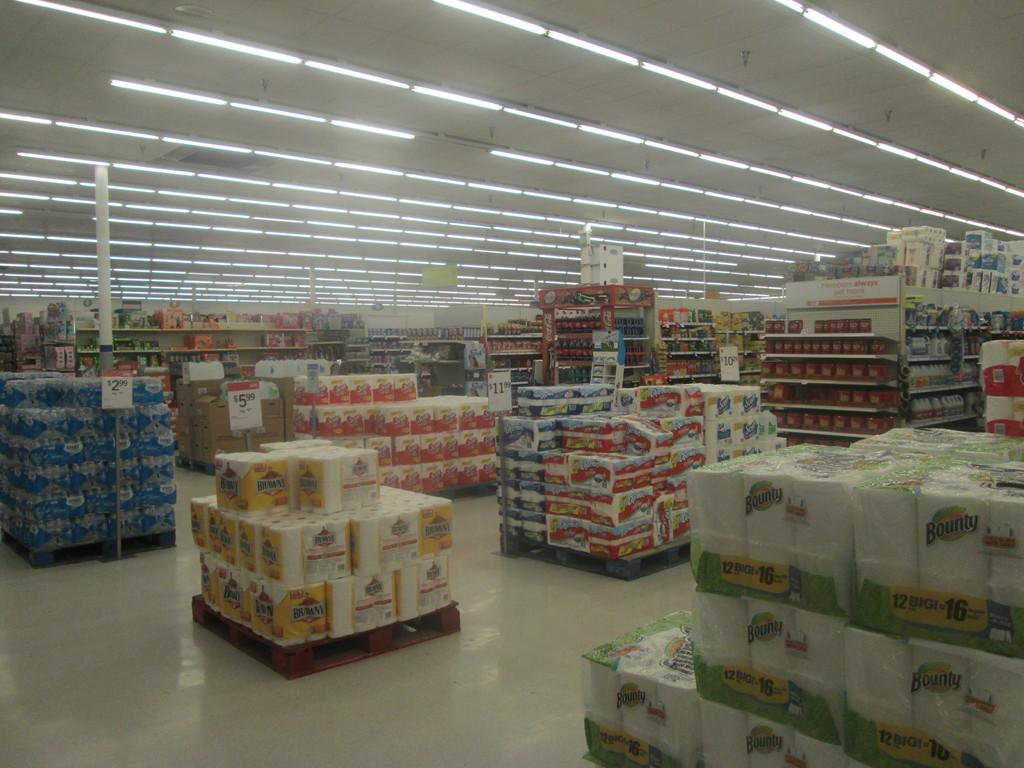<image>
Give a short and clear explanation of the subsequent image. A store with products such as Bounty and Brawny displayed 